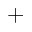Convert formula to latex. <formula><loc_0><loc_0><loc_500><loc_500>^ { + }</formula> 